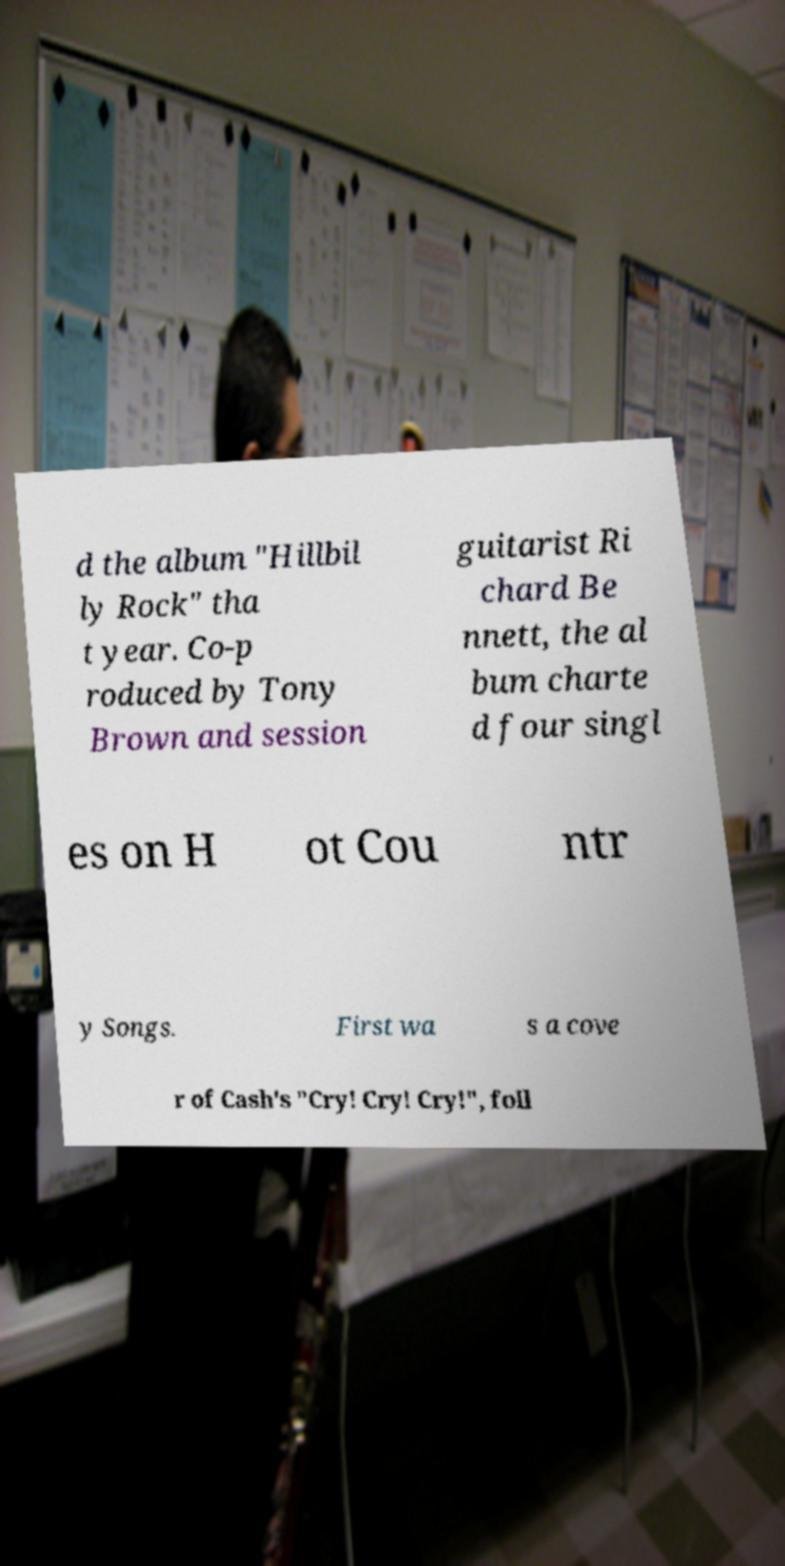What messages or text are displayed in this image? I need them in a readable, typed format. d the album "Hillbil ly Rock" tha t year. Co-p roduced by Tony Brown and session guitarist Ri chard Be nnett, the al bum charte d four singl es on H ot Cou ntr y Songs. First wa s a cove r of Cash's "Cry! Cry! Cry!", foll 